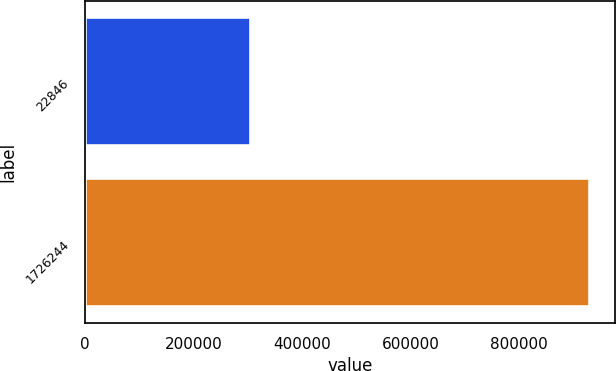<chart> <loc_0><loc_0><loc_500><loc_500><bar_chart><fcel>22846<fcel>1726244<nl><fcel>306490<fcel>930493<nl></chart> 